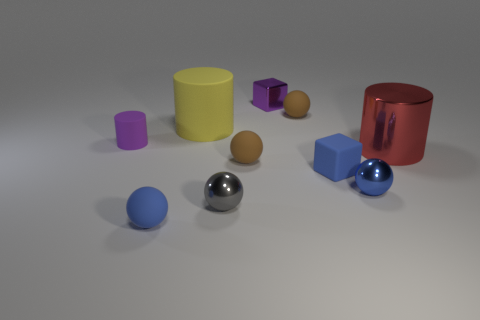What is the cylinder that is on the left side of the blue metallic sphere and on the right side of the small cylinder made of?
Ensure brevity in your answer.  Rubber. How many objects are either small brown shiny cylinders or shiny objects?
Offer a terse response. 4. Are there more tiny things than gray metallic balls?
Provide a succinct answer. Yes. There is a blue rubber object left of the brown matte sphere that is left of the small purple shiny object; how big is it?
Keep it short and to the point. Small. There is a small rubber thing that is the same shape as the red metallic object; what is its color?
Your answer should be compact. Purple. How big is the red thing?
Make the answer very short. Large. How many blocks are blue matte objects or tiny objects?
Give a very brief answer. 2. There is a gray thing that is the same shape as the tiny blue metallic thing; what size is it?
Your answer should be compact. Small. What number of large shiny cylinders are there?
Offer a very short reply. 1. Do the yellow rubber object and the blue matte thing that is on the left side of the large yellow cylinder have the same shape?
Your answer should be compact. No. 